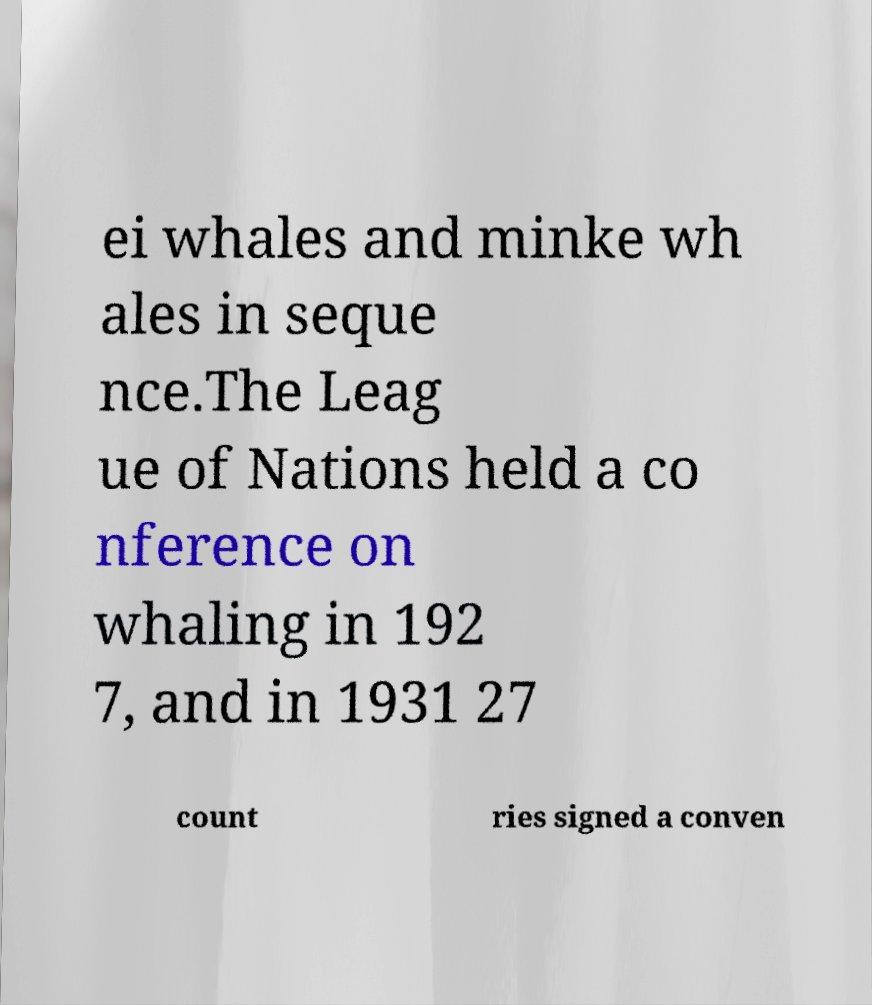Can you read and provide the text displayed in the image?This photo seems to have some interesting text. Can you extract and type it out for me? ei whales and minke wh ales in seque nce.The Leag ue of Nations held a co nference on whaling in 192 7, and in 1931 27 count ries signed a conven 